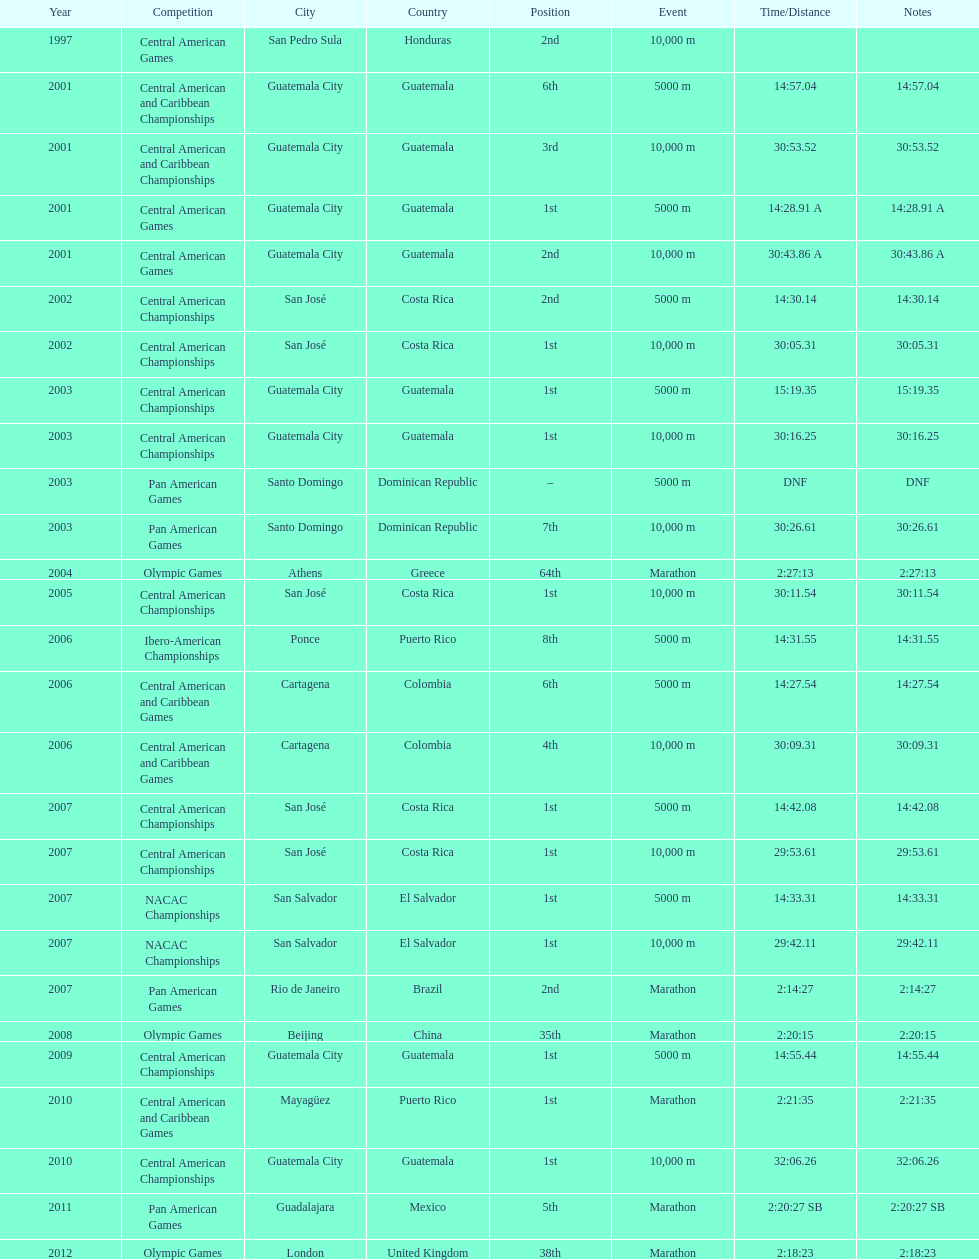Which of each game in 2007 was in the 2nd position? Pan American Games. 